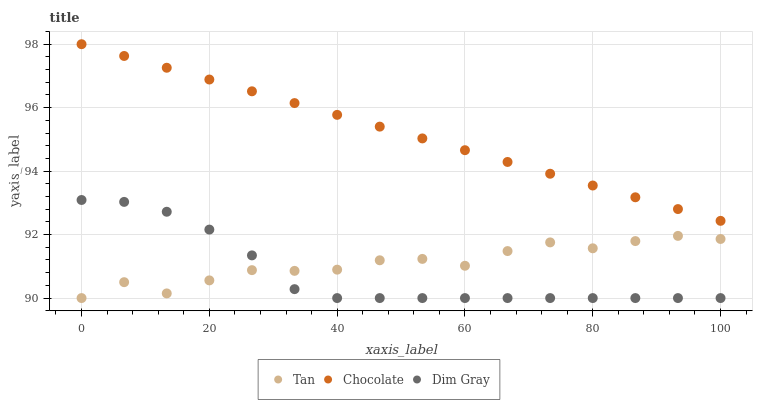Does Dim Gray have the minimum area under the curve?
Answer yes or no. Yes. Does Chocolate have the maximum area under the curve?
Answer yes or no. Yes. Does Chocolate have the minimum area under the curve?
Answer yes or no. No. Does Dim Gray have the maximum area under the curve?
Answer yes or no. No. Is Chocolate the smoothest?
Answer yes or no. Yes. Is Tan the roughest?
Answer yes or no. Yes. Is Dim Gray the smoothest?
Answer yes or no. No. Is Dim Gray the roughest?
Answer yes or no. No. Does Tan have the lowest value?
Answer yes or no. Yes. Does Chocolate have the lowest value?
Answer yes or no. No. Does Chocolate have the highest value?
Answer yes or no. Yes. Does Dim Gray have the highest value?
Answer yes or no. No. Is Tan less than Chocolate?
Answer yes or no. Yes. Is Chocolate greater than Tan?
Answer yes or no. Yes. Does Dim Gray intersect Tan?
Answer yes or no. Yes. Is Dim Gray less than Tan?
Answer yes or no. No. Is Dim Gray greater than Tan?
Answer yes or no. No. Does Tan intersect Chocolate?
Answer yes or no. No. 